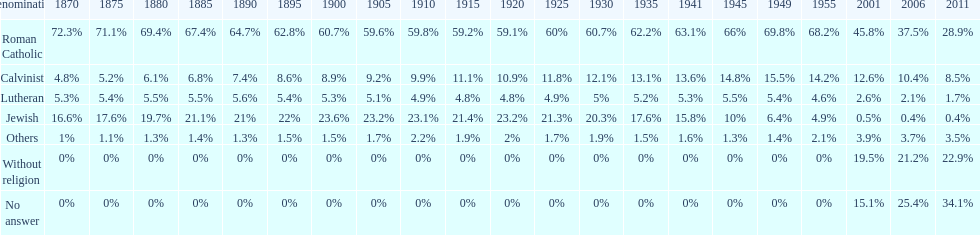What was the highest percentage of individuals identifying as calvinist? 15.5%. Can you parse all the data within this table? {'header': ['Denomination', '1870', '1875', '1880', '1885', '1890', '1895', '1900', '1905', '1910', '1915', '1920', '1925', '1930', '1935', '1941', '1945', '1949', '1955', '2001', '2006', '2011'], 'rows': [['Roman Catholic', '72.3%', '71.1%', '69.4%', '67.4%', '64.7%', '62.8%', '60.7%', '59.6%', '59.8%', '59.2%', '59.1%', '60%', '60.7%', '62.2%', '63.1%', '66%', '69.8%', '68.2%', '45.8%', '37.5%', '28.9%'], ['Calvinist', '4.8%', '5.2%', '6.1%', '6.8%', '7.4%', '8.6%', '8.9%', '9.2%', '9.9%', '11.1%', '10.9%', '11.8%', '12.1%', '13.1%', '13.6%', '14.8%', '15.5%', '14.2%', '12.6%', '10.4%', '8.5%'], ['Lutheran', '5.3%', '5.4%', '5.5%', '5.5%', '5.6%', '5.4%', '5.3%', '5.1%', '4.9%', '4.8%', '4.8%', '4.9%', '5%', '5.2%', '5.3%', '5.5%', '5.4%', '4.6%', '2.6%', '2.1%', '1.7%'], ['Jewish', '16.6%', '17.6%', '19.7%', '21.1%', '21%', '22%', '23.6%', '23.2%', '23.1%', '21.4%', '23.2%', '21.3%', '20.3%', '17.6%', '15.8%', '10%', '6.4%', '4.9%', '0.5%', '0.4%', '0.4%'], ['Others', '1%', '1.1%', '1.3%', '1.4%', '1.3%', '1.5%', '1.5%', '1.7%', '2.2%', '1.9%', '2%', '1.7%', '1.9%', '1.5%', '1.6%', '1.3%', '1.4%', '2.1%', '3.9%', '3.7%', '3.5%'], ['Without religion', '0%', '0%', '0%', '0%', '0%', '0%', '0%', '0%', '0%', '0%', '0%', '0%', '0%', '0%', '0%', '0%', '0%', '0%', '19.5%', '21.2%', '22.9%'], ['No answer', '0%', '0%', '0%', '0%', '0%', '0%', '0%', '0%', '0%', '0%', '0%', '0%', '0%', '0%', '0%', '0%', '0%', '0%', '15.1%', '25.4%', '34.1%']]} 